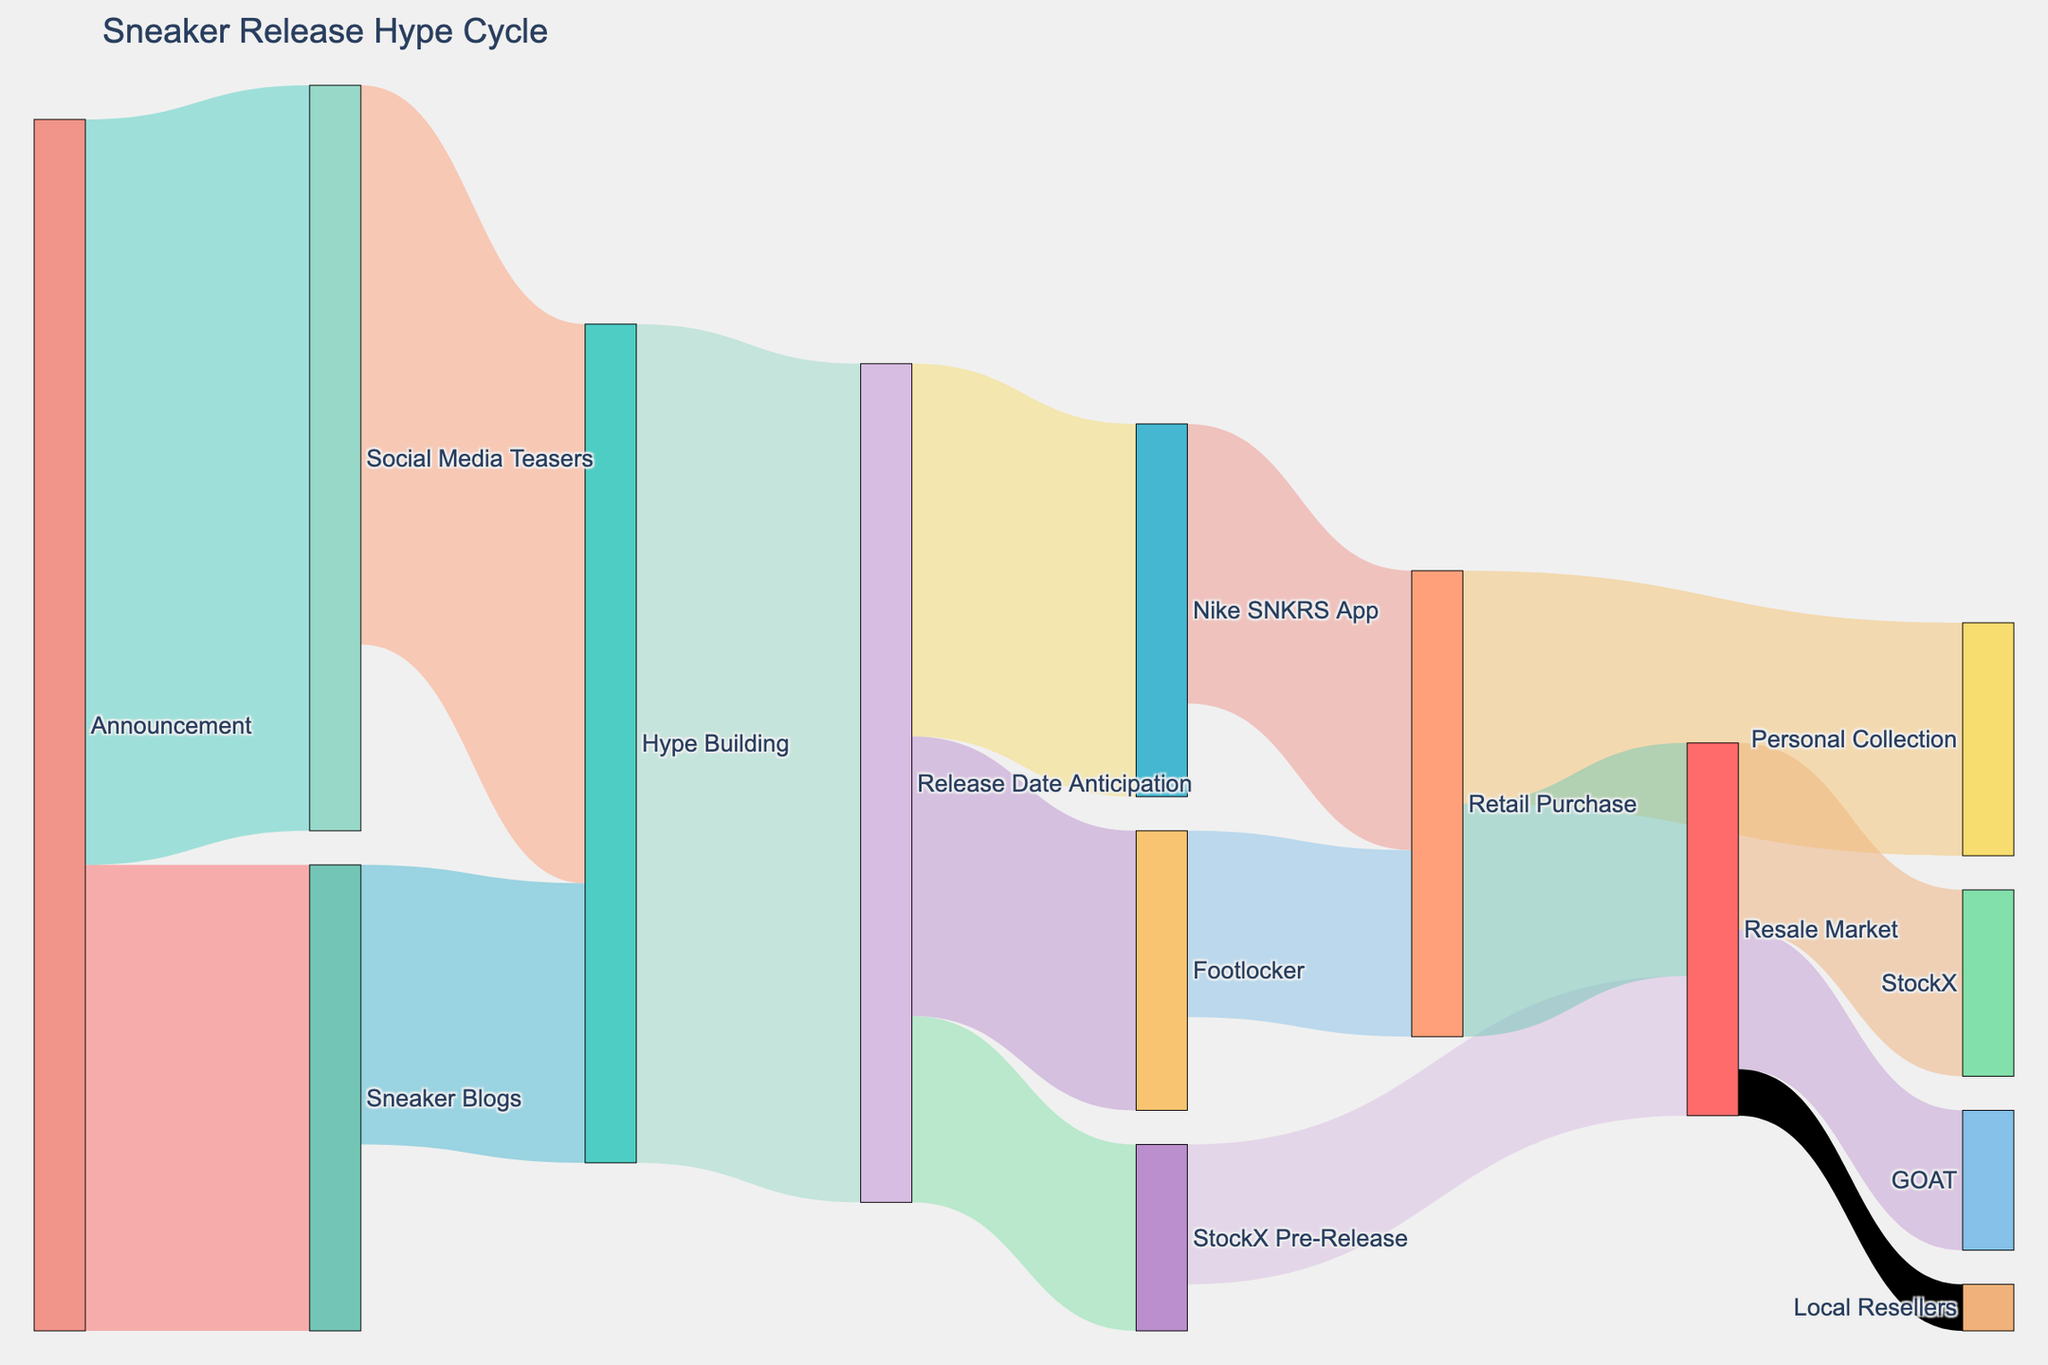What's the main purpose of the Sankey Diagram? The diagram is used to illustrate the flow of sneaker release hype from the initial announcement to resale, showing stages of buzz and market interest. By analyzing the flows between different stages, we can understand how sneaker hype builds up and eventually translates into market behavior.
Answer: To show sneaker release hype cycle Which stages immediately follow the 'Announcement'? The 'Announcement' stage is directly connected to 'Sneaker Blogs' and 'Social Media Teasers'.
Answer: Sneaker Blogs and Social Media Teasers How many units of interest flow from 'Announcement' to 'Social Media Teasers'? The diagram shows a flow of 8000 units from 'Announcement' to 'Social Media Teasers'.
Answer: 8000 What is the total value flowing into the 'Hype Building' stage? To get the total value flowing into 'Hype Building', sum the values from 'Sneaker Blogs' (3000) and 'Social Media Teasers' (6000). The total flow is 3000 + 6000 = 9000 units.
Answer: 9000 Which stage has more units flowing into 'Resale Market', 'Retail Purchase' or 'StockX Pre-Release'? To determine this, compare the values: Retail Purchase to Resale Market (2500) and StockX Pre-Release to Resale Market (1500). 2500 > 1500, Retail Purchase has more units flowing into 'Resale Market'.
Answer: Retail Purchase In 'Resale Market', which target receives the largest flow of units? According to the diagram, 'StockX' receives the largest flow with 2000 units, compared to 'GOAT' (1500) and 'Local Resellers' (500).
Answer: StockX What is the total flow of units from the 'Release Date Anticipation' stage? Sum the values of all outflows from 'Release Date Anticipation', which are to 'Nike SNKRS App' (4000), 'Footlocker' (3000), and 'StockX Pre-Release' (2000). The total is 4000 + 3000 + 2000 = 9000 units.
Answer: 9000 What stage receives flow from both 'Nike SNKRS App' and 'Footlocker'? The stage 'Retail Purchase' receives flows from both 'Nike SNKRS App' (3000) and 'Footlocker' (2000).
Answer: Retail Purchase 